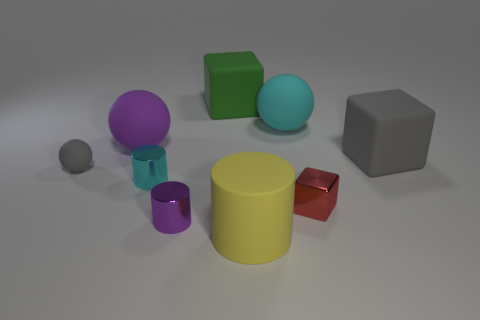Which object in the image is the largest? The yellow cylinder appears to be the largest object in the image. 